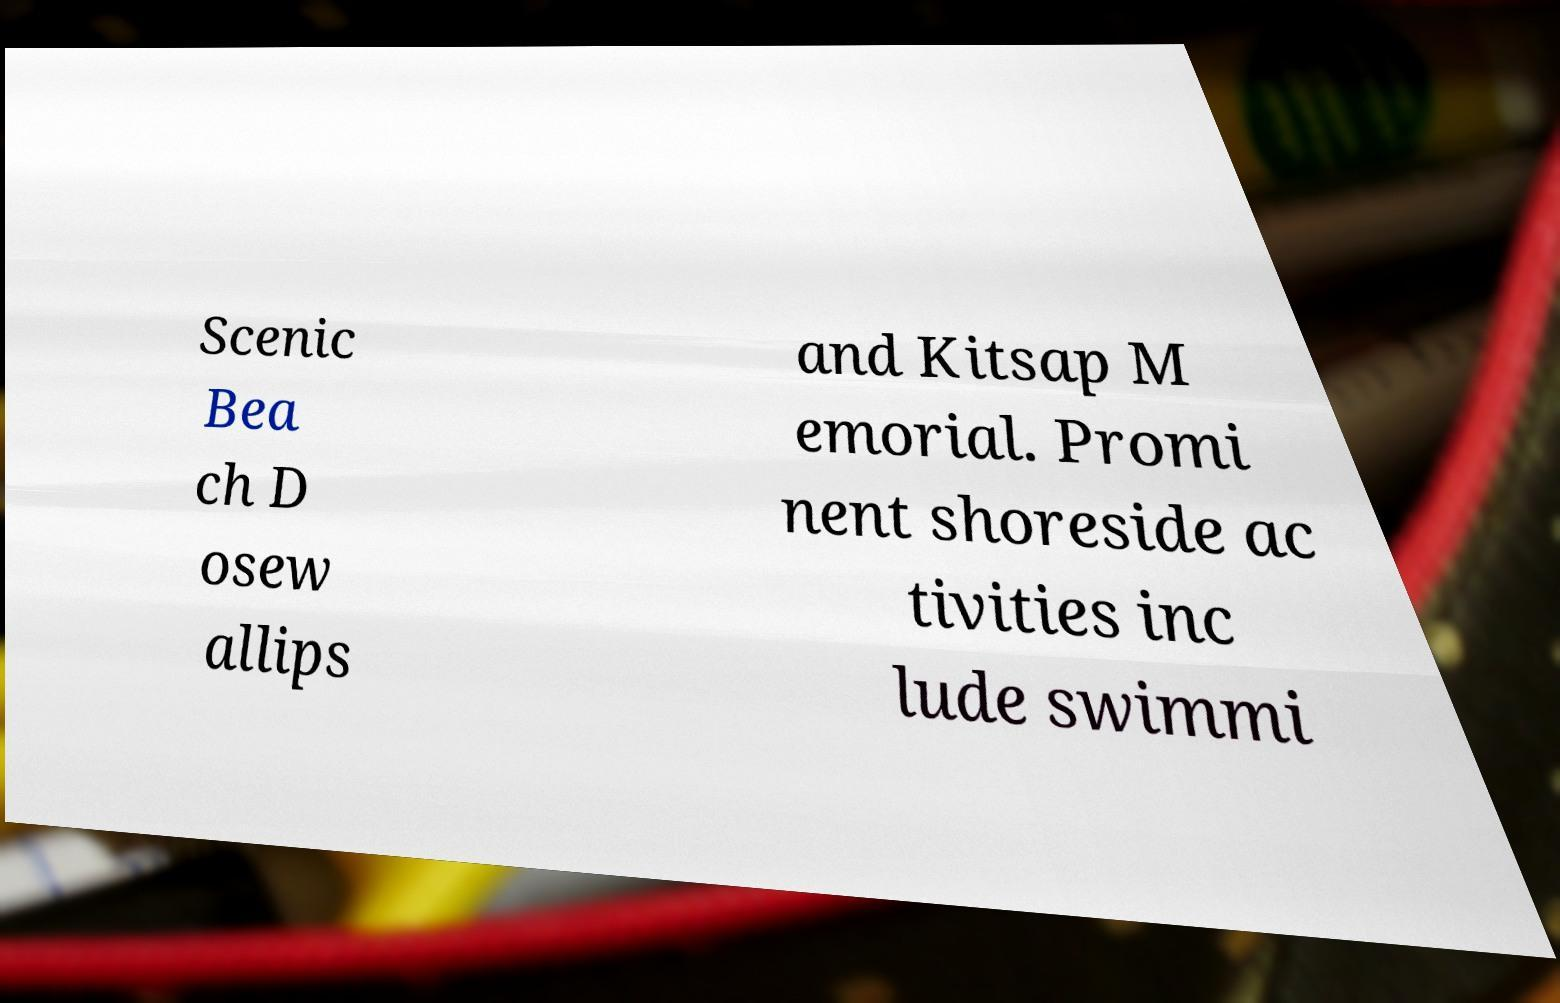Please identify and transcribe the text found in this image. Scenic Bea ch D osew allips and Kitsap M emorial. Promi nent shoreside ac tivities inc lude swimmi 